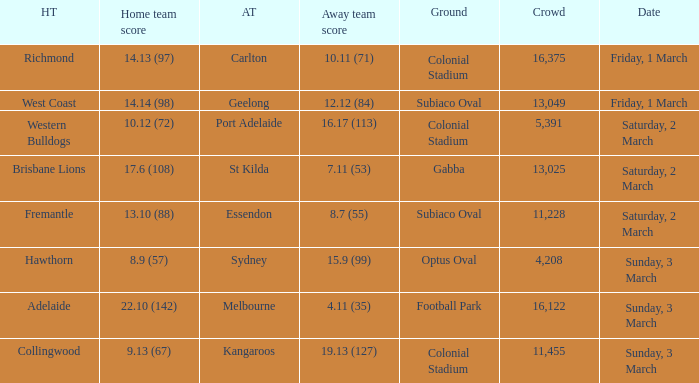6 (108)? St Kilda. 